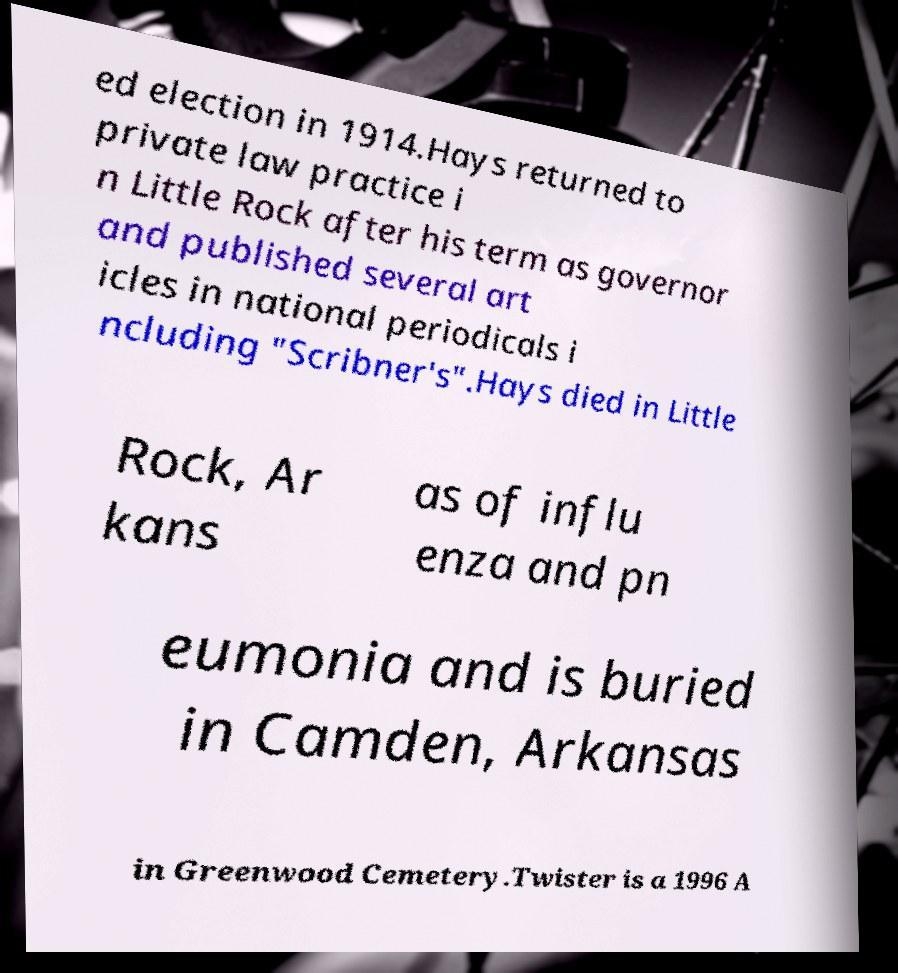Can you accurately transcribe the text from the provided image for me? ed election in 1914.Hays returned to private law practice i n Little Rock after his term as governor and published several art icles in national periodicals i ncluding "Scribner's".Hays died in Little Rock, Ar kans as of influ enza and pn eumonia and is buried in Camden, Arkansas in Greenwood Cemetery.Twister is a 1996 A 